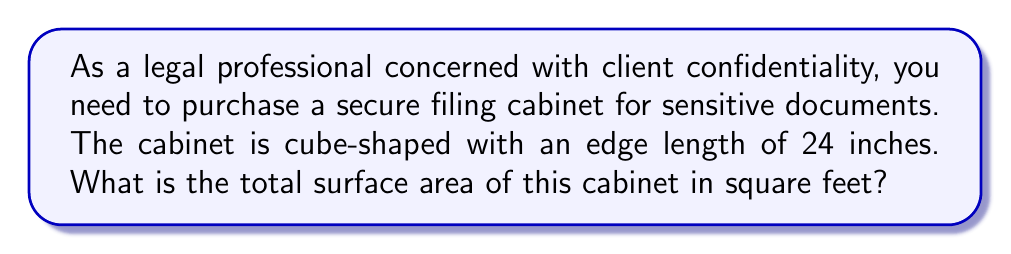Provide a solution to this math problem. To solve this problem, we'll follow these steps:

1. Recall the formula for the surface area of a cube:
   $$SA = 6a^2$$
   where $a$ is the length of an edge.

2. Convert the given edge length from inches to feet:
   $$24 \text{ inches} = 24 \div 12 = 2 \text{ feet}$$

3. Apply the surface area formula:
   $$\begin{align*}
   SA &= 6a^2 \\
   &= 6 \cdot (2 \text{ ft})^2 \\
   &= 6 \cdot 4 \text{ ft}^2 \\
   &= 24 \text{ ft}^2
   \end{align*}$$

Therefore, the total surface area of the cube-shaped secure filing cabinet is 24 square feet.
Answer: $24 \text{ ft}^2$ 